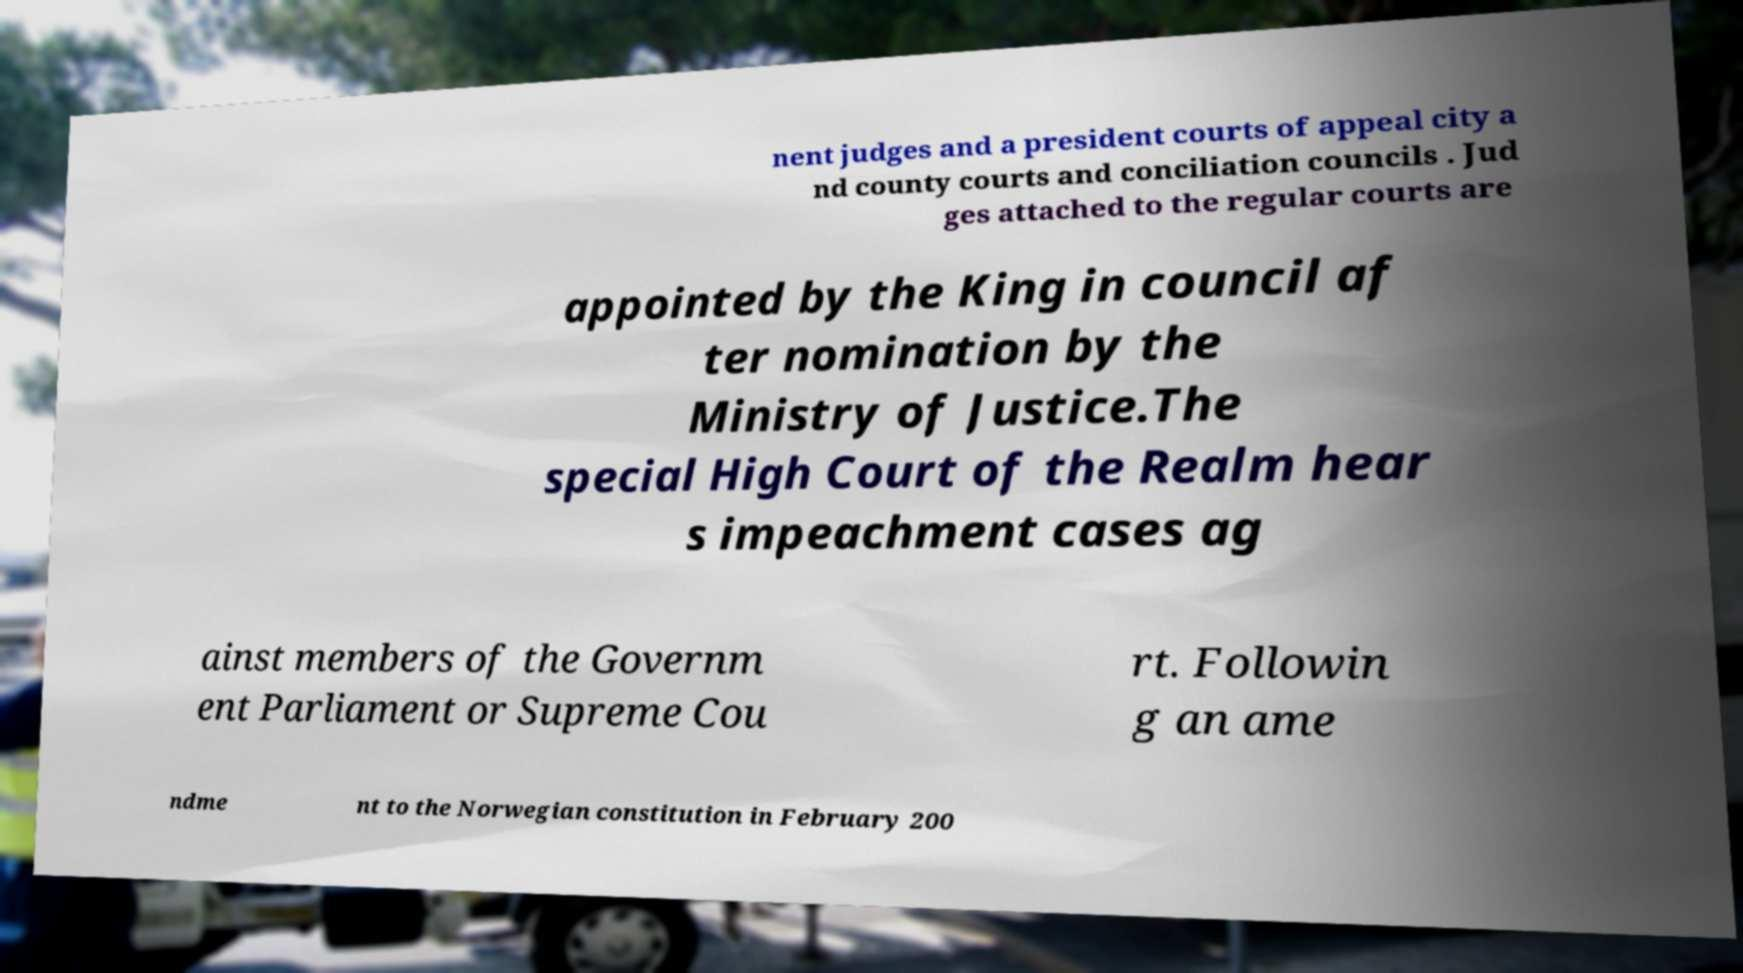Could you assist in decoding the text presented in this image and type it out clearly? nent judges and a president courts of appeal city a nd county courts and conciliation councils . Jud ges attached to the regular courts are appointed by the King in council af ter nomination by the Ministry of Justice.The special High Court of the Realm hear s impeachment cases ag ainst members of the Governm ent Parliament or Supreme Cou rt. Followin g an ame ndme nt to the Norwegian constitution in February 200 